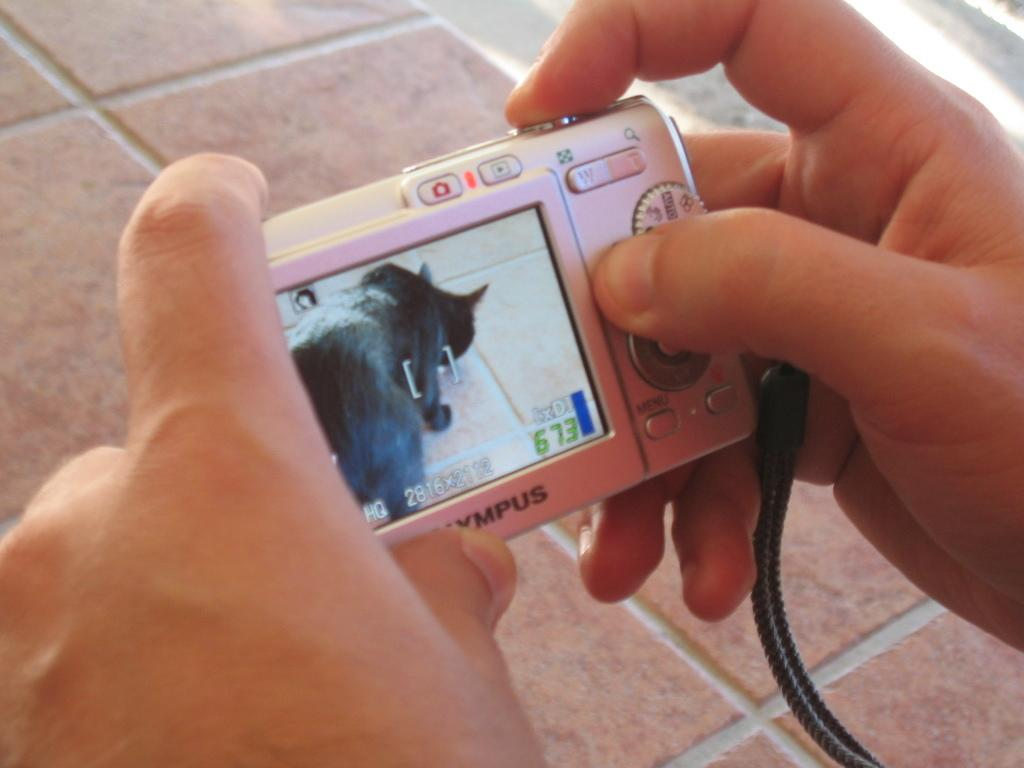What is being held by the hands in the image? The hands are holding a camera. Can you describe the hands in the image? The hands belong to a person, but no other details about the person are provided. How does the grandmother help the laborer with his cough in the image? There is no grandmother, laborer, or cough present in the image. The image only shows hands holding a camera. 